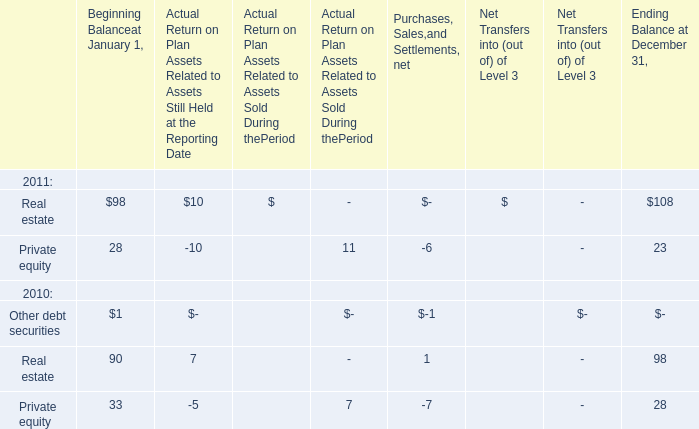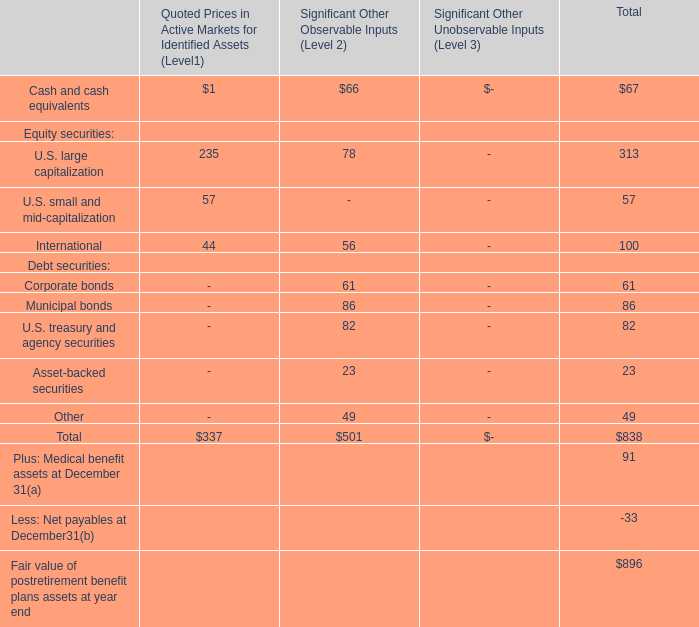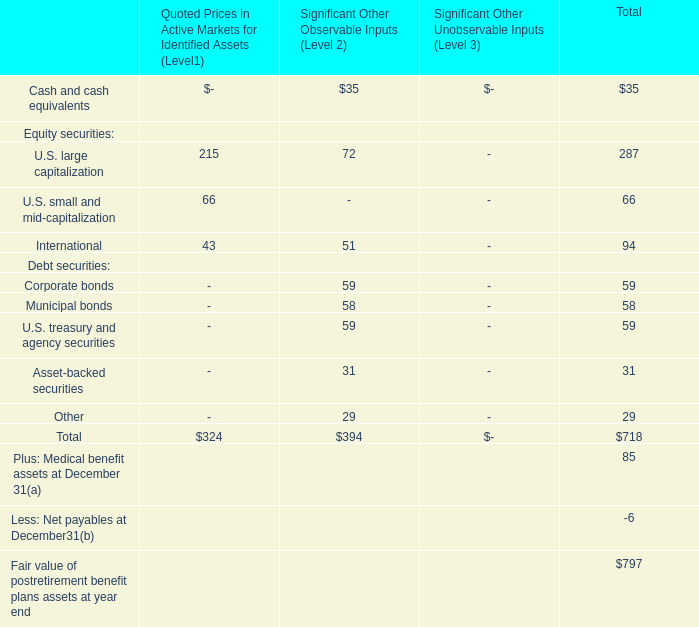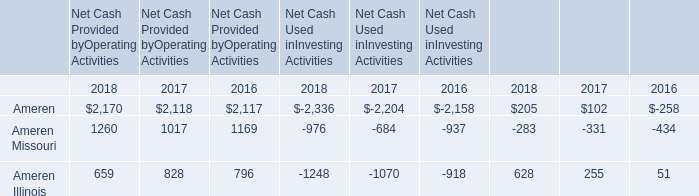Which year is Private equity of Beginning Balanceat January 1 the least? 
Answer: 2011. 